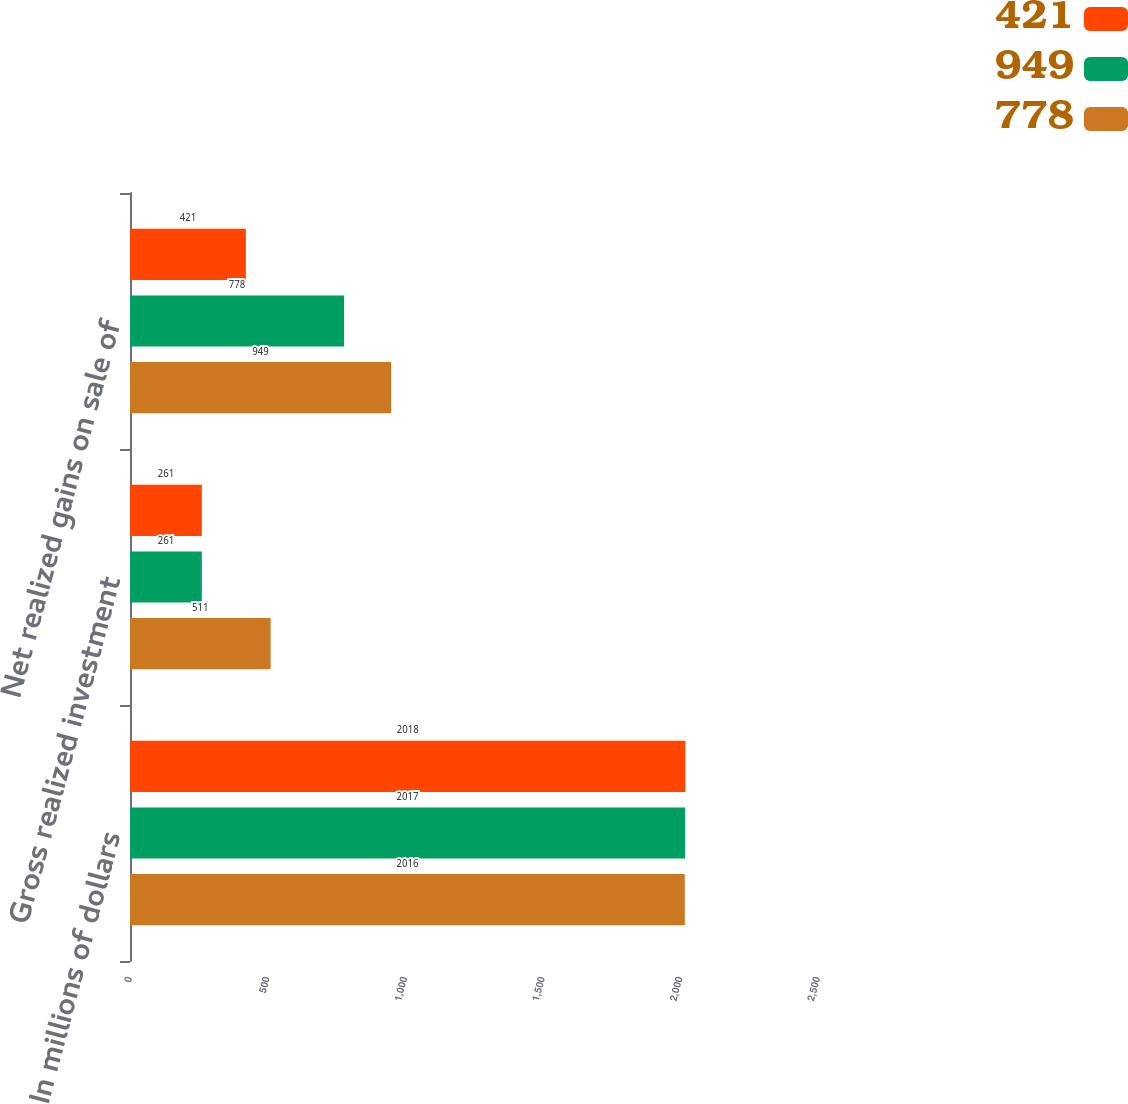Convert chart. <chart><loc_0><loc_0><loc_500><loc_500><stacked_bar_chart><ecel><fcel>In millions of dollars<fcel>Gross realized investment<fcel>Net realized gains on sale of<nl><fcel>421<fcel>2018<fcel>261<fcel>421<nl><fcel>949<fcel>2017<fcel>261<fcel>778<nl><fcel>778<fcel>2016<fcel>511<fcel>949<nl></chart> 